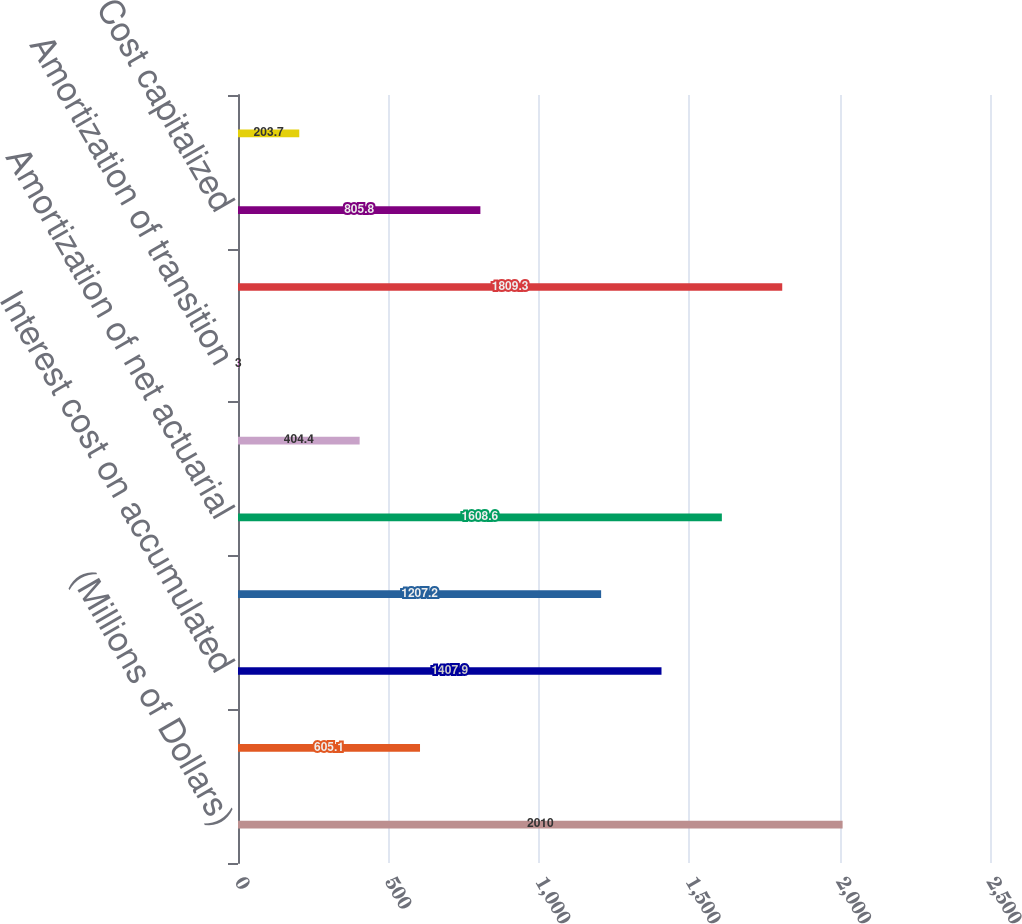Convert chart to OTSL. <chart><loc_0><loc_0><loc_500><loc_500><bar_chart><fcel>(Millions of Dollars)<fcel>Service cost<fcel>Interest cost on accumulated<fcel>Expected return on plan assets<fcel>Amortization of net actuarial<fcel>Amortization of prior service<fcel>Amortization of transition<fcel>NET PERIODIC POSTRETIREMENT<fcel>Cost capitalized<fcel>Cost charged/(deferred)<nl><fcel>2010<fcel>605.1<fcel>1407.9<fcel>1207.2<fcel>1608.6<fcel>404.4<fcel>3<fcel>1809.3<fcel>805.8<fcel>203.7<nl></chart> 